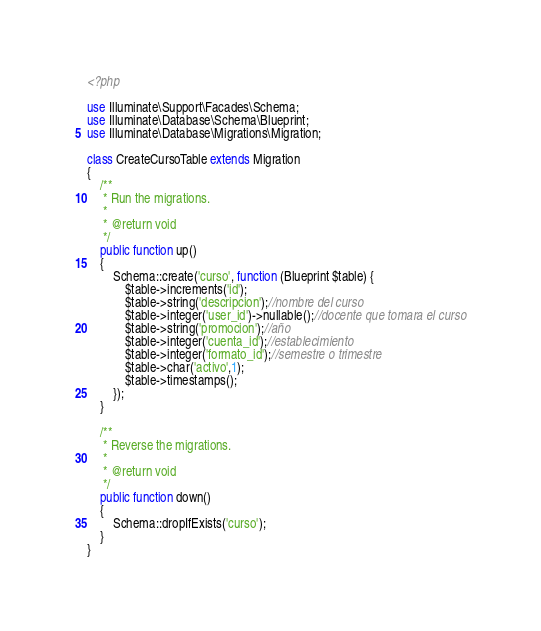<code> <loc_0><loc_0><loc_500><loc_500><_PHP_><?php

use Illuminate\Support\Facades\Schema;
use Illuminate\Database\Schema\Blueprint;
use Illuminate\Database\Migrations\Migration;

class CreateCursoTable extends Migration
{
    /**
     * Run the migrations.
     *
     * @return void
     */
    public function up()
    {
        Schema::create('curso', function (Blueprint $table) {
            $table->increments('id');
            $table->string('descripcion');//nombre del curso
            $table->integer('user_id')->nullable();//docente que tomara el curso
            $table->string('promocion');//año
            $table->integer('cuenta_id');//establecimiento
            $table->integer('formato_id');//semestre o trimestre
            $table->char('activo',1);
            $table->timestamps();
        });
    }

    /**
     * Reverse the migrations.
     *
     * @return void
     */
    public function down()
    {
        Schema::dropIfExists('curso');
    }
}
</code> 